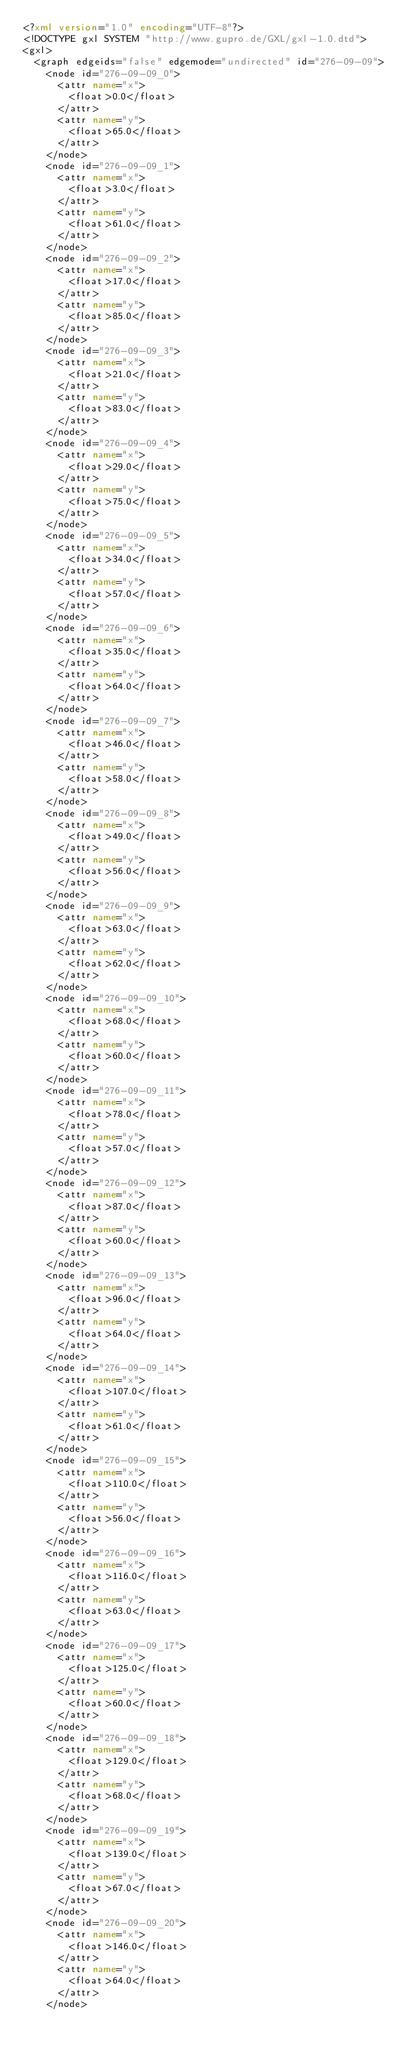Convert code to text. <code><loc_0><loc_0><loc_500><loc_500><_XML_><?xml version="1.0" encoding="UTF-8"?>
<!DOCTYPE gxl SYSTEM "http://www.gupro.de/GXL/gxl-1.0.dtd">
<gxl>
	<graph edgeids="false" edgemode="undirected" id="276-09-09">
		<node id="276-09-09_0">
			<attr name="x">
				<float>0.0</float>
			</attr>
			<attr name="y">
				<float>65.0</float>
			</attr>
		</node>
		<node id="276-09-09_1">
			<attr name="x">
				<float>3.0</float>
			</attr>
			<attr name="y">
				<float>61.0</float>
			</attr>
		</node>
		<node id="276-09-09_2">
			<attr name="x">
				<float>17.0</float>
			</attr>
			<attr name="y">
				<float>85.0</float>
			</attr>
		</node>
		<node id="276-09-09_3">
			<attr name="x">
				<float>21.0</float>
			</attr>
			<attr name="y">
				<float>83.0</float>
			</attr>
		</node>
		<node id="276-09-09_4">
			<attr name="x">
				<float>29.0</float>
			</attr>
			<attr name="y">
				<float>75.0</float>
			</attr>
		</node>
		<node id="276-09-09_5">
			<attr name="x">
				<float>34.0</float>
			</attr>
			<attr name="y">
				<float>57.0</float>
			</attr>
		</node>
		<node id="276-09-09_6">
			<attr name="x">
				<float>35.0</float>
			</attr>
			<attr name="y">
				<float>64.0</float>
			</attr>
		</node>
		<node id="276-09-09_7">
			<attr name="x">
				<float>46.0</float>
			</attr>
			<attr name="y">
				<float>58.0</float>
			</attr>
		</node>
		<node id="276-09-09_8">
			<attr name="x">
				<float>49.0</float>
			</attr>
			<attr name="y">
				<float>56.0</float>
			</attr>
		</node>
		<node id="276-09-09_9">
			<attr name="x">
				<float>63.0</float>
			</attr>
			<attr name="y">
				<float>62.0</float>
			</attr>
		</node>
		<node id="276-09-09_10">
			<attr name="x">
				<float>68.0</float>
			</attr>
			<attr name="y">
				<float>60.0</float>
			</attr>
		</node>
		<node id="276-09-09_11">
			<attr name="x">
				<float>78.0</float>
			</attr>
			<attr name="y">
				<float>57.0</float>
			</attr>
		</node>
		<node id="276-09-09_12">
			<attr name="x">
				<float>87.0</float>
			</attr>
			<attr name="y">
				<float>60.0</float>
			</attr>
		</node>
		<node id="276-09-09_13">
			<attr name="x">
				<float>96.0</float>
			</attr>
			<attr name="y">
				<float>64.0</float>
			</attr>
		</node>
		<node id="276-09-09_14">
			<attr name="x">
				<float>107.0</float>
			</attr>
			<attr name="y">
				<float>61.0</float>
			</attr>
		</node>
		<node id="276-09-09_15">
			<attr name="x">
				<float>110.0</float>
			</attr>
			<attr name="y">
				<float>56.0</float>
			</attr>
		</node>
		<node id="276-09-09_16">
			<attr name="x">
				<float>116.0</float>
			</attr>
			<attr name="y">
				<float>63.0</float>
			</attr>
		</node>
		<node id="276-09-09_17">
			<attr name="x">
				<float>125.0</float>
			</attr>
			<attr name="y">
				<float>60.0</float>
			</attr>
		</node>
		<node id="276-09-09_18">
			<attr name="x">
				<float>129.0</float>
			</attr>
			<attr name="y">
				<float>68.0</float>
			</attr>
		</node>
		<node id="276-09-09_19">
			<attr name="x">
				<float>139.0</float>
			</attr>
			<attr name="y">
				<float>67.0</float>
			</attr>
		</node>
		<node id="276-09-09_20">
			<attr name="x">
				<float>146.0</float>
			</attr>
			<attr name="y">
				<float>64.0</float>
			</attr>
		</node></code> 